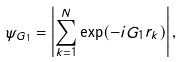<formula> <loc_0><loc_0><loc_500><loc_500>\psi _ { G _ { 1 } } = \left | \sum _ { k = 1 } ^ { N } \exp ( - i G _ { 1 } r _ { k } ) \right | ,</formula> 